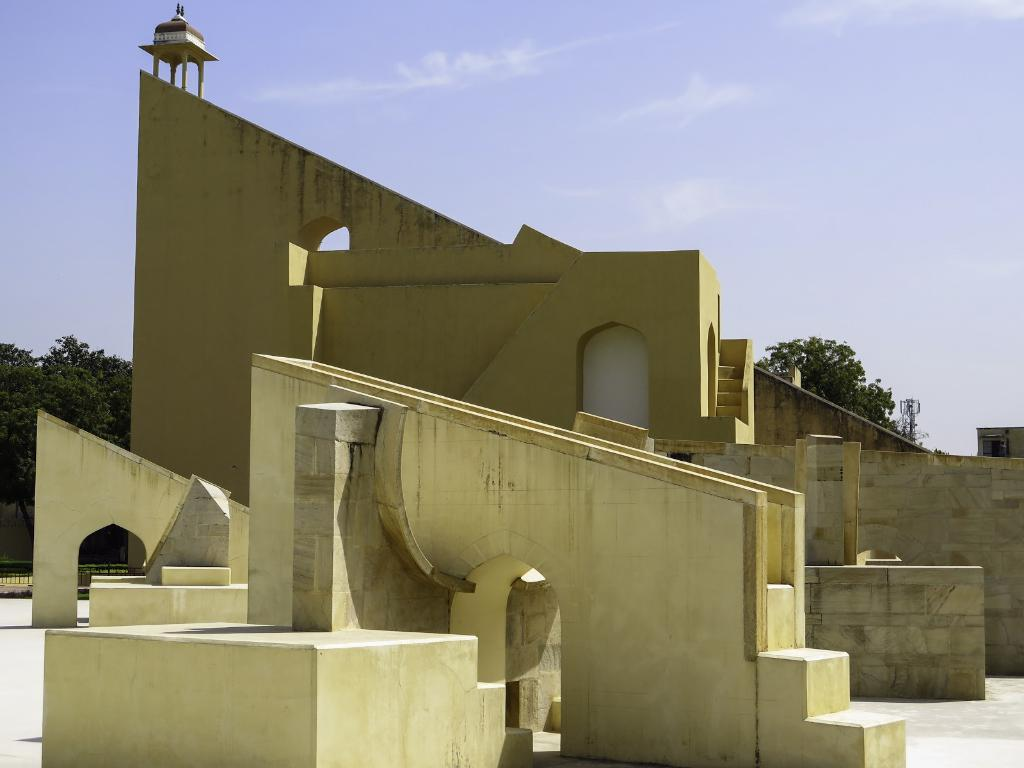What type of structure is in the image? There is a building in the image. What color is the building? The building is in light yellow color. What can be seen in the background of the image? There are trees and the sky visible in the background of the image. What color are the trees? The trees are in green color. What color is the sky? The sky is in blue and white color. What type of wax is being used for the competition in the image? There is no competition or wax present in the image. The image only features a building, trees, and the sky. 